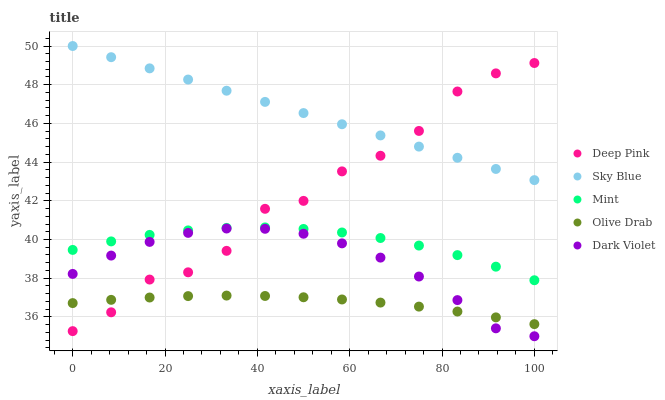Does Olive Drab have the minimum area under the curve?
Answer yes or no. Yes. Does Sky Blue have the maximum area under the curve?
Answer yes or no. Yes. Does Deep Pink have the minimum area under the curve?
Answer yes or no. No. Does Deep Pink have the maximum area under the curve?
Answer yes or no. No. Is Sky Blue the smoothest?
Answer yes or no. Yes. Is Deep Pink the roughest?
Answer yes or no. Yes. Is Mint the smoothest?
Answer yes or no. No. Is Mint the roughest?
Answer yes or no. No. Does Dark Violet have the lowest value?
Answer yes or no. Yes. Does Deep Pink have the lowest value?
Answer yes or no. No. Does Sky Blue have the highest value?
Answer yes or no. Yes. Does Deep Pink have the highest value?
Answer yes or no. No. Is Olive Drab less than Sky Blue?
Answer yes or no. Yes. Is Mint greater than Olive Drab?
Answer yes or no. Yes. Does Deep Pink intersect Mint?
Answer yes or no. Yes. Is Deep Pink less than Mint?
Answer yes or no. No. Is Deep Pink greater than Mint?
Answer yes or no. No. Does Olive Drab intersect Sky Blue?
Answer yes or no. No. 